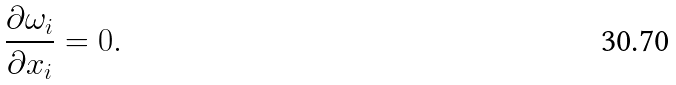Convert formula to latex. <formula><loc_0><loc_0><loc_500><loc_500>\frac { \partial \omega _ { i } } { \partial x _ { i } } = 0 .</formula> 